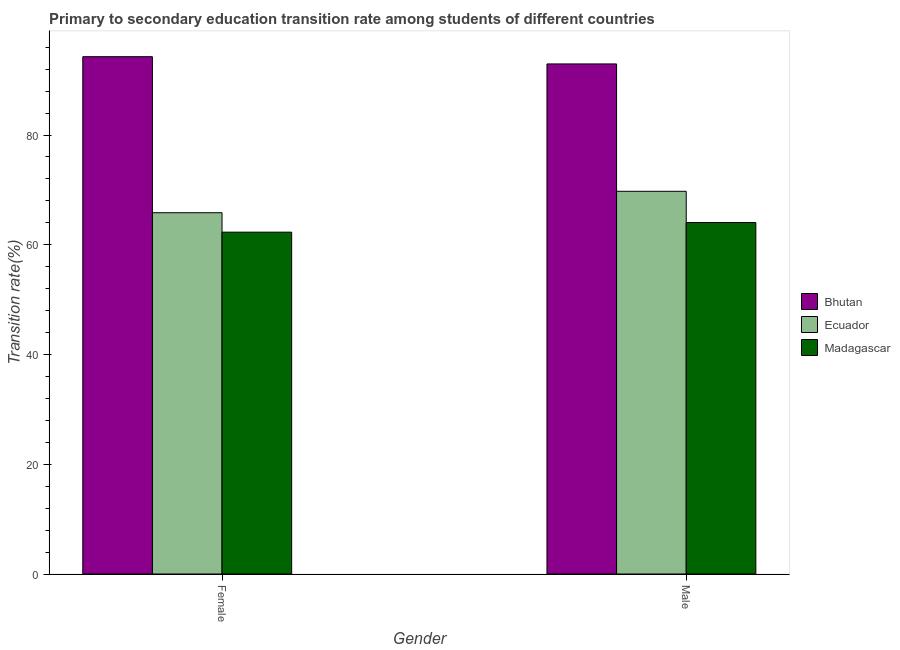How many groups of bars are there?
Give a very brief answer. 2. Are the number of bars per tick equal to the number of legend labels?
Offer a terse response. Yes. Are the number of bars on each tick of the X-axis equal?
Keep it short and to the point. Yes. How many bars are there on the 1st tick from the left?
Provide a short and direct response. 3. What is the label of the 2nd group of bars from the left?
Ensure brevity in your answer.  Male. What is the transition rate among male students in Bhutan?
Provide a succinct answer. 92.95. Across all countries, what is the maximum transition rate among male students?
Offer a terse response. 92.95. Across all countries, what is the minimum transition rate among female students?
Provide a short and direct response. 62.29. In which country was the transition rate among male students maximum?
Give a very brief answer. Bhutan. In which country was the transition rate among female students minimum?
Your response must be concise. Madagascar. What is the total transition rate among male students in the graph?
Your answer should be very brief. 226.74. What is the difference between the transition rate among male students in Madagascar and that in Ecuador?
Ensure brevity in your answer.  -5.7. What is the difference between the transition rate among female students in Madagascar and the transition rate among male students in Bhutan?
Your answer should be very brief. -30.66. What is the average transition rate among male students per country?
Your answer should be very brief. 75.58. What is the difference between the transition rate among female students and transition rate among male students in Bhutan?
Your answer should be very brief. 1.32. What is the ratio of the transition rate among female students in Madagascar to that in Bhutan?
Keep it short and to the point. 0.66. In how many countries, is the transition rate among male students greater than the average transition rate among male students taken over all countries?
Give a very brief answer. 1. What does the 2nd bar from the left in Female represents?
Offer a terse response. Ecuador. What does the 3rd bar from the right in Male represents?
Provide a succinct answer. Bhutan. Are all the bars in the graph horizontal?
Give a very brief answer. No. How many countries are there in the graph?
Provide a succinct answer. 3. Does the graph contain any zero values?
Your answer should be compact. No. What is the title of the graph?
Make the answer very short. Primary to secondary education transition rate among students of different countries. What is the label or title of the Y-axis?
Keep it short and to the point. Transition rate(%). What is the Transition rate(%) of Bhutan in Female?
Keep it short and to the point. 94.27. What is the Transition rate(%) in Ecuador in Female?
Offer a very short reply. 65.84. What is the Transition rate(%) of Madagascar in Female?
Offer a terse response. 62.29. What is the Transition rate(%) of Bhutan in Male?
Your answer should be very brief. 92.95. What is the Transition rate(%) in Ecuador in Male?
Ensure brevity in your answer.  69.74. What is the Transition rate(%) in Madagascar in Male?
Offer a very short reply. 64.04. Across all Gender, what is the maximum Transition rate(%) in Bhutan?
Offer a very short reply. 94.27. Across all Gender, what is the maximum Transition rate(%) in Ecuador?
Your response must be concise. 69.74. Across all Gender, what is the maximum Transition rate(%) of Madagascar?
Offer a terse response. 64.04. Across all Gender, what is the minimum Transition rate(%) in Bhutan?
Make the answer very short. 92.95. Across all Gender, what is the minimum Transition rate(%) of Ecuador?
Keep it short and to the point. 65.84. Across all Gender, what is the minimum Transition rate(%) in Madagascar?
Your response must be concise. 62.29. What is the total Transition rate(%) of Bhutan in the graph?
Provide a succinct answer. 187.23. What is the total Transition rate(%) in Ecuador in the graph?
Make the answer very short. 135.58. What is the total Transition rate(%) of Madagascar in the graph?
Ensure brevity in your answer.  126.34. What is the difference between the Transition rate(%) in Bhutan in Female and that in Male?
Ensure brevity in your answer.  1.32. What is the difference between the Transition rate(%) in Ecuador in Female and that in Male?
Your answer should be compact. -3.91. What is the difference between the Transition rate(%) of Madagascar in Female and that in Male?
Your response must be concise. -1.75. What is the difference between the Transition rate(%) of Bhutan in Female and the Transition rate(%) of Ecuador in Male?
Ensure brevity in your answer.  24.53. What is the difference between the Transition rate(%) in Bhutan in Female and the Transition rate(%) in Madagascar in Male?
Your answer should be compact. 30.23. What is the difference between the Transition rate(%) of Ecuador in Female and the Transition rate(%) of Madagascar in Male?
Your answer should be very brief. 1.79. What is the average Transition rate(%) of Bhutan per Gender?
Keep it short and to the point. 93.61. What is the average Transition rate(%) of Ecuador per Gender?
Offer a terse response. 67.79. What is the average Transition rate(%) in Madagascar per Gender?
Give a very brief answer. 63.17. What is the difference between the Transition rate(%) of Bhutan and Transition rate(%) of Ecuador in Female?
Your response must be concise. 28.43. What is the difference between the Transition rate(%) in Bhutan and Transition rate(%) in Madagascar in Female?
Give a very brief answer. 31.98. What is the difference between the Transition rate(%) of Ecuador and Transition rate(%) of Madagascar in Female?
Provide a short and direct response. 3.54. What is the difference between the Transition rate(%) of Bhutan and Transition rate(%) of Ecuador in Male?
Give a very brief answer. 23.21. What is the difference between the Transition rate(%) of Bhutan and Transition rate(%) of Madagascar in Male?
Offer a very short reply. 28.91. What is the difference between the Transition rate(%) in Ecuador and Transition rate(%) in Madagascar in Male?
Offer a terse response. 5.7. What is the ratio of the Transition rate(%) in Bhutan in Female to that in Male?
Provide a short and direct response. 1.01. What is the ratio of the Transition rate(%) in Ecuador in Female to that in Male?
Your answer should be compact. 0.94. What is the ratio of the Transition rate(%) in Madagascar in Female to that in Male?
Make the answer very short. 0.97. What is the difference between the highest and the second highest Transition rate(%) in Bhutan?
Offer a terse response. 1.32. What is the difference between the highest and the second highest Transition rate(%) in Ecuador?
Make the answer very short. 3.91. What is the difference between the highest and the second highest Transition rate(%) in Madagascar?
Your response must be concise. 1.75. What is the difference between the highest and the lowest Transition rate(%) in Bhutan?
Provide a succinct answer. 1.32. What is the difference between the highest and the lowest Transition rate(%) in Ecuador?
Offer a very short reply. 3.91. What is the difference between the highest and the lowest Transition rate(%) in Madagascar?
Give a very brief answer. 1.75. 